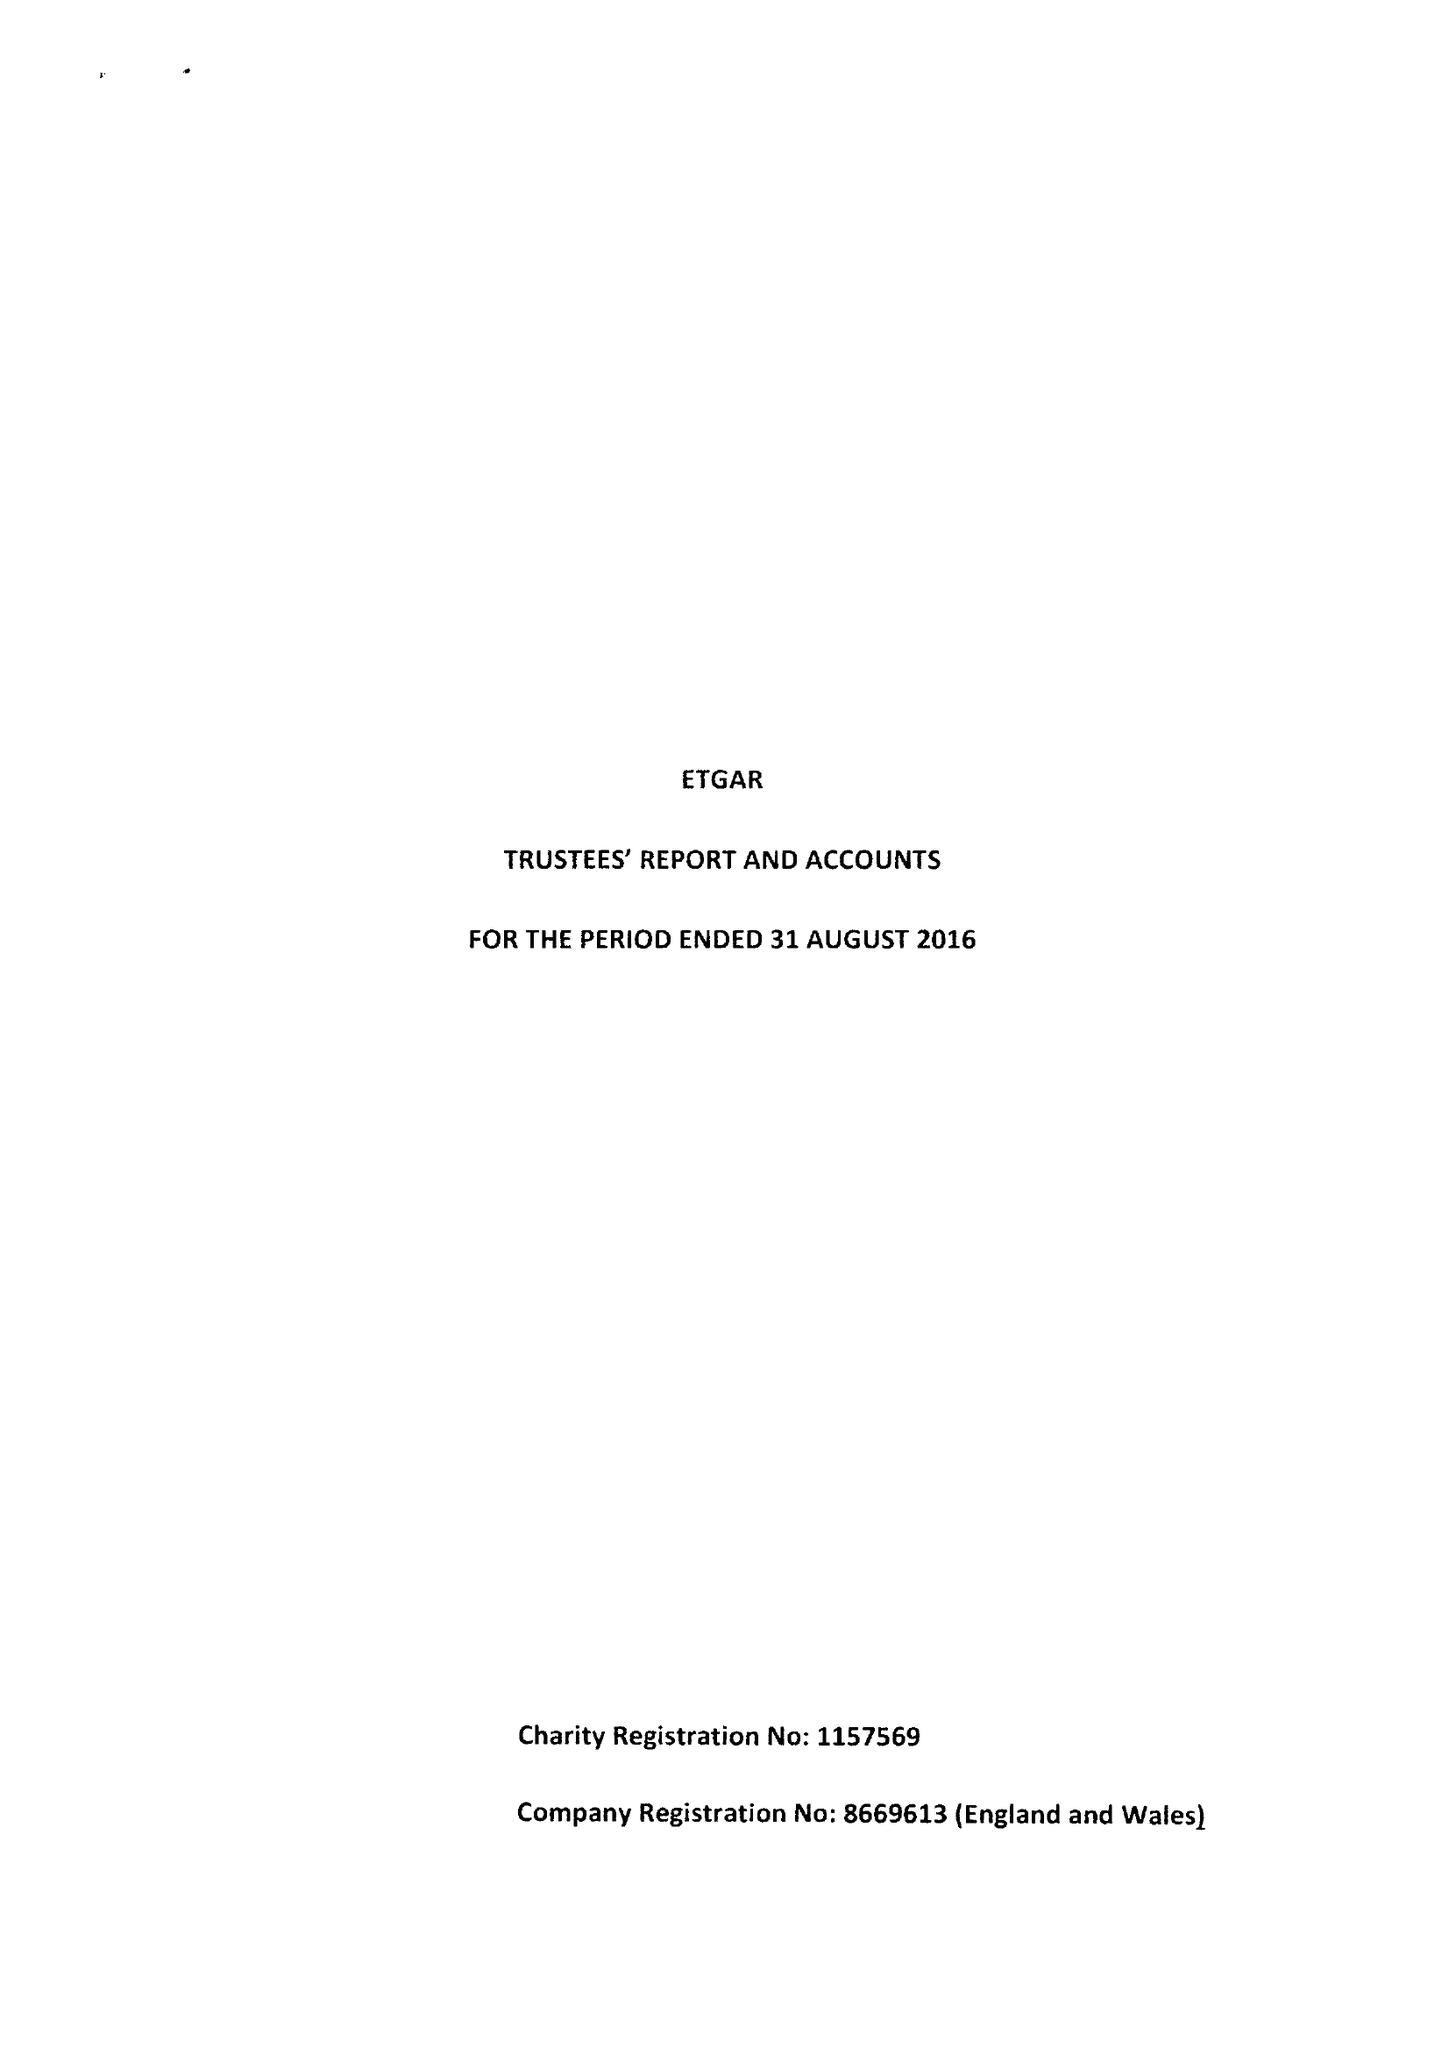What is the value for the report_date?
Answer the question using a single word or phrase. 2016-08-30 